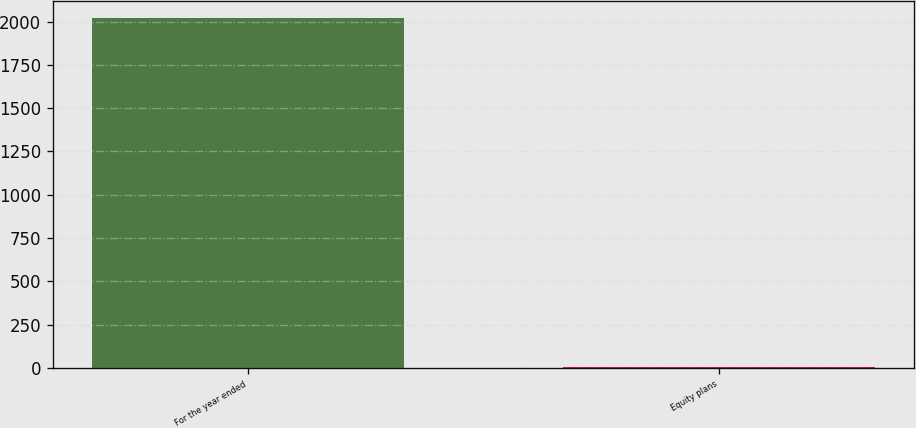Convert chart to OTSL. <chart><loc_0><loc_0><loc_500><loc_500><bar_chart><fcel>For the year ended<fcel>Equity plans<nl><fcel>2018<fcel>3<nl></chart> 